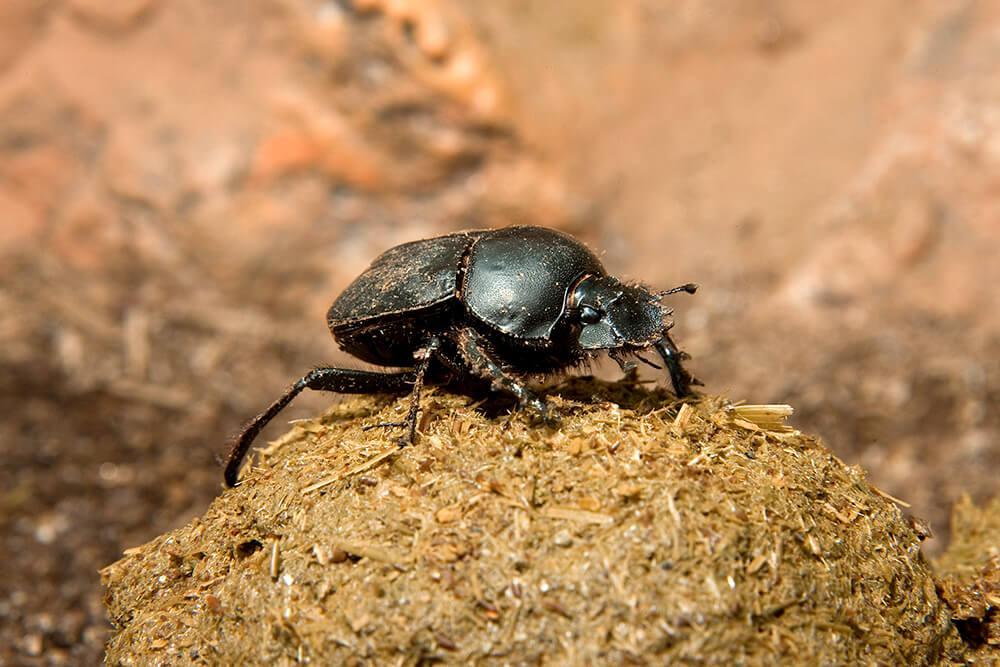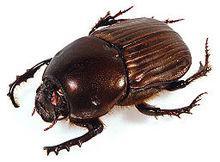The first image is the image on the left, the second image is the image on the right. Evaluate the accuracy of this statement regarding the images: "Both images show a beetle in contact with a round dung ball.". Is it true? Answer yes or no. No. The first image is the image on the left, the second image is the image on the right. Given the left and right images, does the statement "There is a beetle that that's at the very top of a dungball." hold true? Answer yes or no. Yes. The first image is the image on the left, the second image is the image on the right. Analyze the images presented: Is the assertion "At least one of the beetles is not on a clod of dirt." valid? Answer yes or no. Yes. The first image is the image on the left, the second image is the image on the right. For the images shown, is this caption "An image shows a beetle standing directly on top of a dung ball, with its body horizontal." true? Answer yes or no. Yes. 